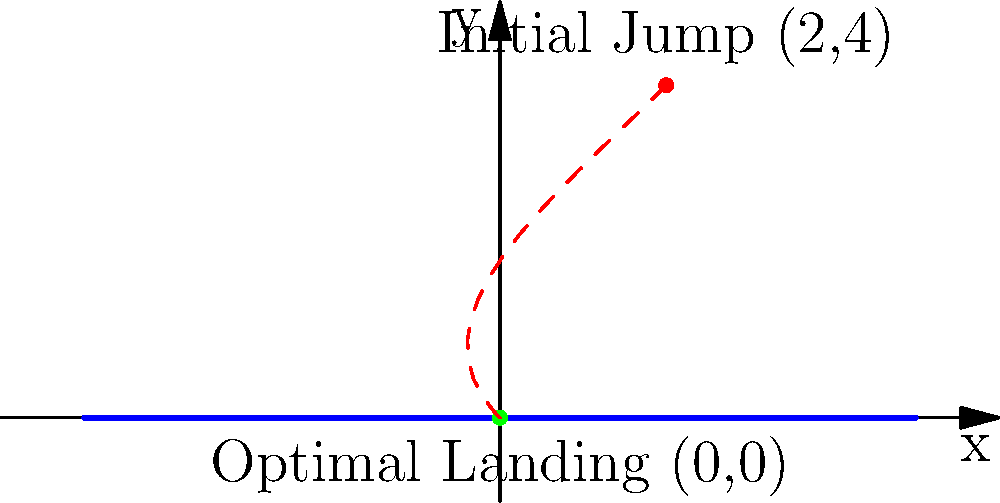A gymnast performs a jump on a trampoline, initiating from the point $(2,4)$. The trampoline's surface is represented by the x-axis, spanning from $x=-5$ to $x=5$. Assuming the gymnast's trajectory follows a parabolic path, determine the optimal landing coordinates $(x,y)$ on the trampoline that would minimize the horizontal distance traveled while maintaining a smooth landing angle. How would you guide the gymnast to achieve this optimal landing? To solve this problem, we'll follow these steps:

1) The parabolic trajectory of the jump can be described by the equation:
   $$y = a(x-h)^2 + k$$
   where $(h,k)$ is the vertex of the parabola.

2) We know two points on this parabola: the initial jump point $(2,4)$ and the landing point on the x-axis $(x,0)$.

3) For a smooth landing, the parabola should be symmetrical. This means the vertex should be halfway between the initial jump point and the landing point.

4) To minimize horizontal distance, the landing point should be as close to the initial x-coordinate as possible while maintaining symmetry.

5) The optimal landing point is directly below the midpoint between the initial jump point and the vertex. This occurs at $x=0$.

6) The vertex of the parabola will be at $(\frac{2+0}{2}, 4) = (1,4)$.

7) We can verify this by substituting into the parabola equation:
   $4 = a(2-1)^2 + 4$
   $0 = a(0-1)^2 + 4$

8) Solving these equations confirms that $a=-4$.

9) Therefore, the optimal landing point is $(0,0)$.

To guide the gymnast:
- Instruct them to aim for the center of the trampoline (x=0).
- Emphasize the importance of maintaining a symmetrical arc in their jump.
- Encourage them to visualize the midpoint of their trajectory at (1,4).
Answer: $(0,0)$ 